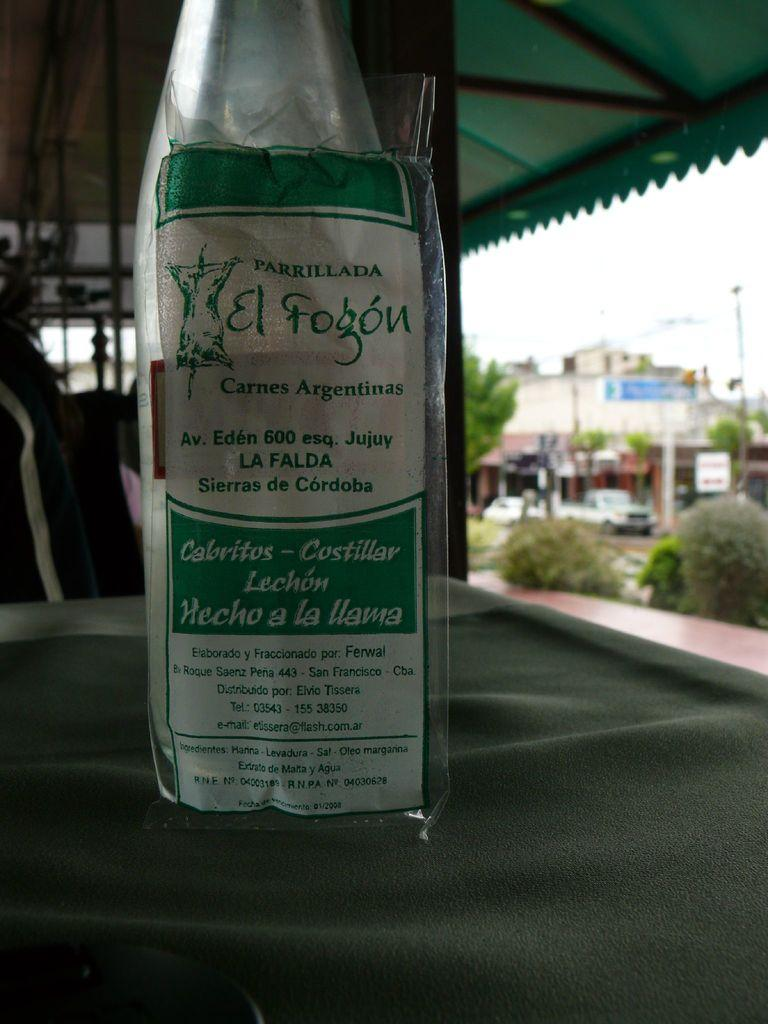<image>
Summarize the visual content of the image. the word lechon that is on a wine bottle 